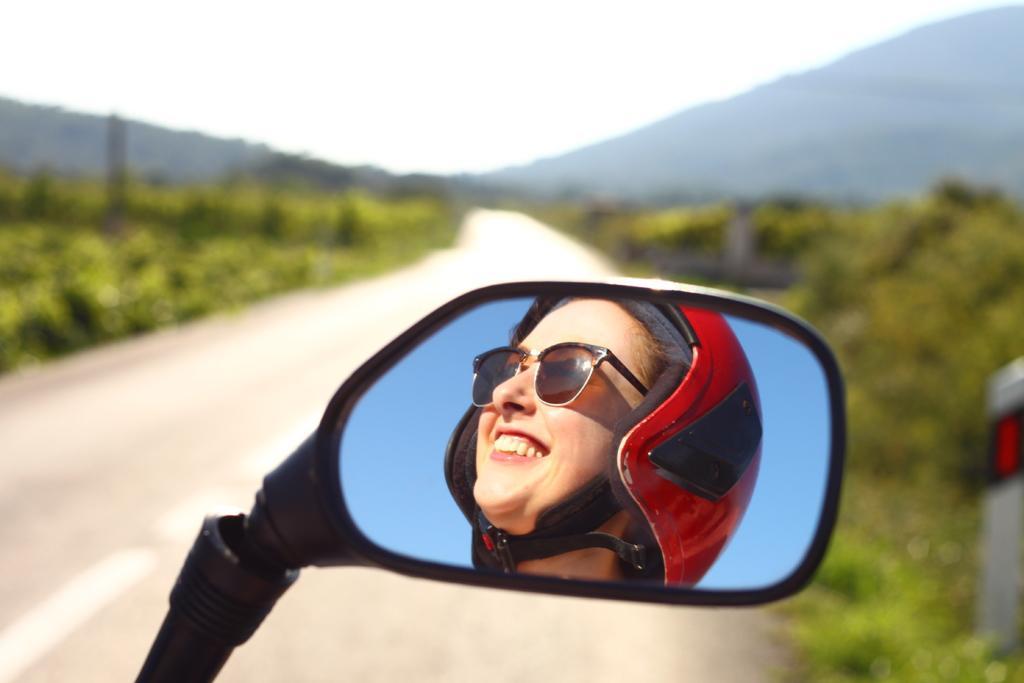Describe this image in one or two sentences. In the center we can see the reflection of a person wearing helmet and sunglasses in the mirror. In the background we can see the sky, green leaves, ground and some other objects. 